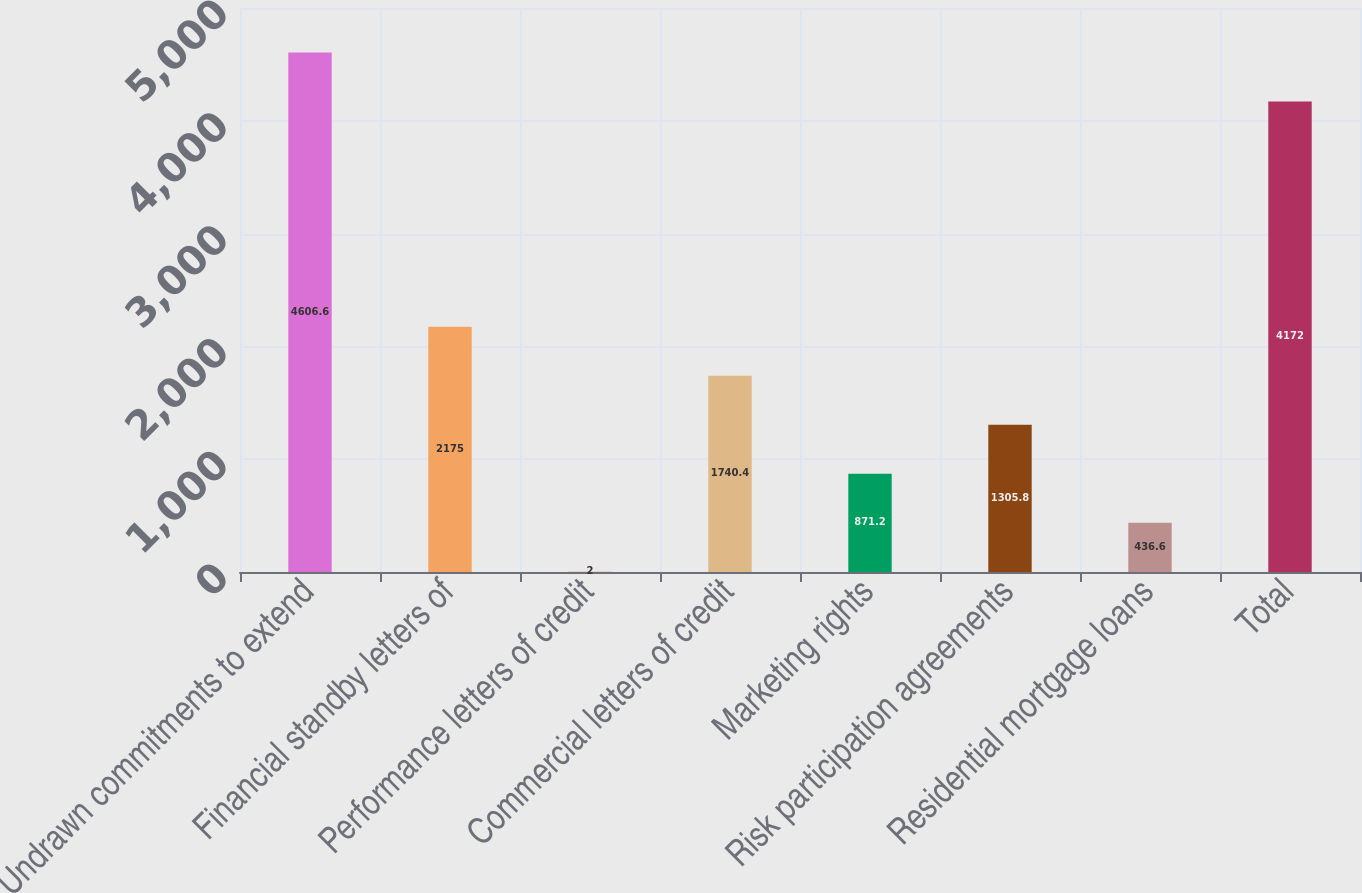Convert chart. <chart><loc_0><loc_0><loc_500><loc_500><bar_chart><fcel>Undrawn commitments to extend<fcel>Financial standby letters of<fcel>Performance letters of credit<fcel>Commercial letters of credit<fcel>Marketing rights<fcel>Risk participation agreements<fcel>Residential mortgage loans<fcel>Total<nl><fcel>4606.6<fcel>2175<fcel>2<fcel>1740.4<fcel>871.2<fcel>1305.8<fcel>436.6<fcel>4172<nl></chart> 